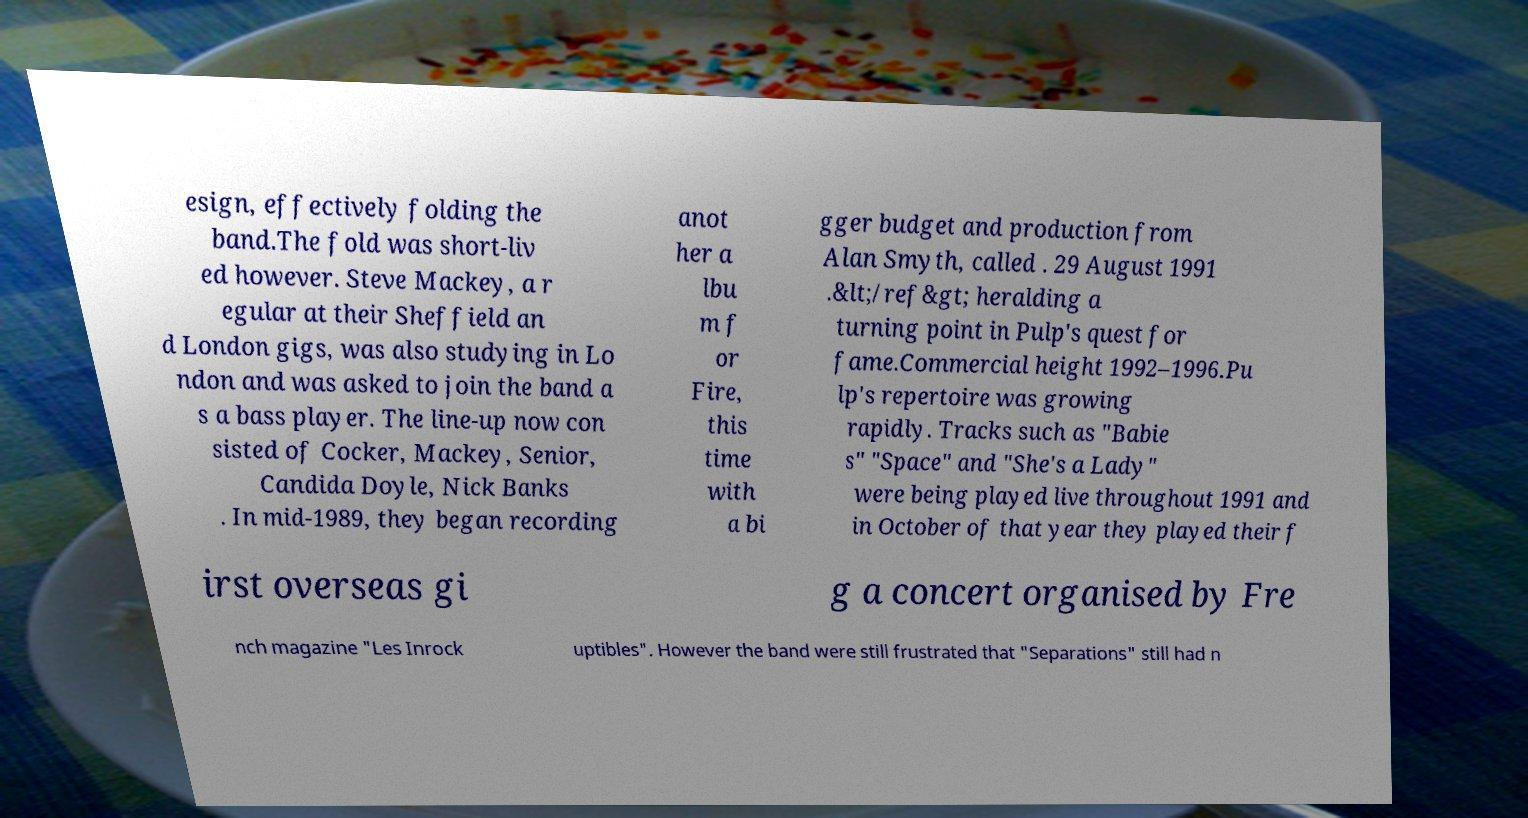Could you extract and type out the text from this image? esign, effectively folding the band.The fold was short-liv ed however. Steve Mackey, a r egular at their Sheffield an d London gigs, was also studying in Lo ndon and was asked to join the band a s a bass player. The line-up now con sisted of Cocker, Mackey, Senior, Candida Doyle, Nick Banks . In mid-1989, they began recording anot her a lbu m f or Fire, this time with a bi gger budget and production from Alan Smyth, called . 29 August 1991 .&lt;/ref&gt; heralding a turning point in Pulp's quest for fame.Commercial height 1992–1996.Pu lp's repertoire was growing rapidly. Tracks such as "Babie s" "Space" and "She's a Lady" were being played live throughout 1991 and in October of that year they played their f irst overseas gi g a concert organised by Fre nch magazine "Les Inrock uptibles". However the band were still frustrated that "Separations" still had n 